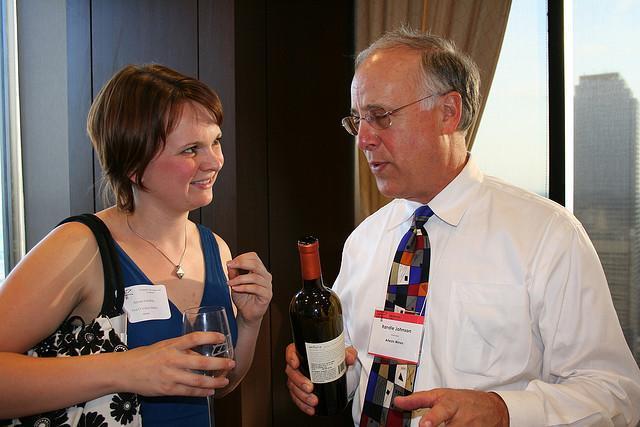How many name tags do you see?
Give a very brief answer. 2. How many pairs of glasses?
Give a very brief answer. 1. How many handbags can you see?
Give a very brief answer. 1. How many ties can be seen?
Give a very brief answer. 1. How many people are in the photo?
Give a very brief answer. 2. How many buses are behind a street sign?
Give a very brief answer. 0. 